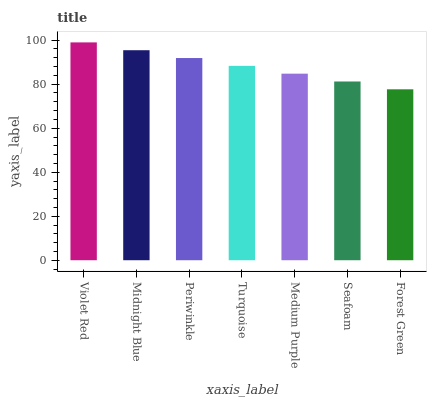Is Forest Green the minimum?
Answer yes or no. Yes. Is Violet Red the maximum?
Answer yes or no. Yes. Is Midnight Blue the minimum?
Answer yes or no. No. Is Midnight Blue the maximum?
Answer yes or no. No. Is Violet Red greater than Midnight Blue?
Answer yes or no. Yes. Is Midnight Blue less than Violet Red?
Answer yes or no. Yes. Is Midnight Blue greater than Violet Red?
Answer yes or no. No. Is Violet Red less than Midnight Blue?
Answer yes or no. No. Is Turquoise the high median?
Answer yes or no. Yes. Is Turquoise the low median?
Answer yes or no. Yes. Is Violet Red the high median?
Answer yes or no. No. Is Midnight Blue the low median?
Answer yes or no. No. 